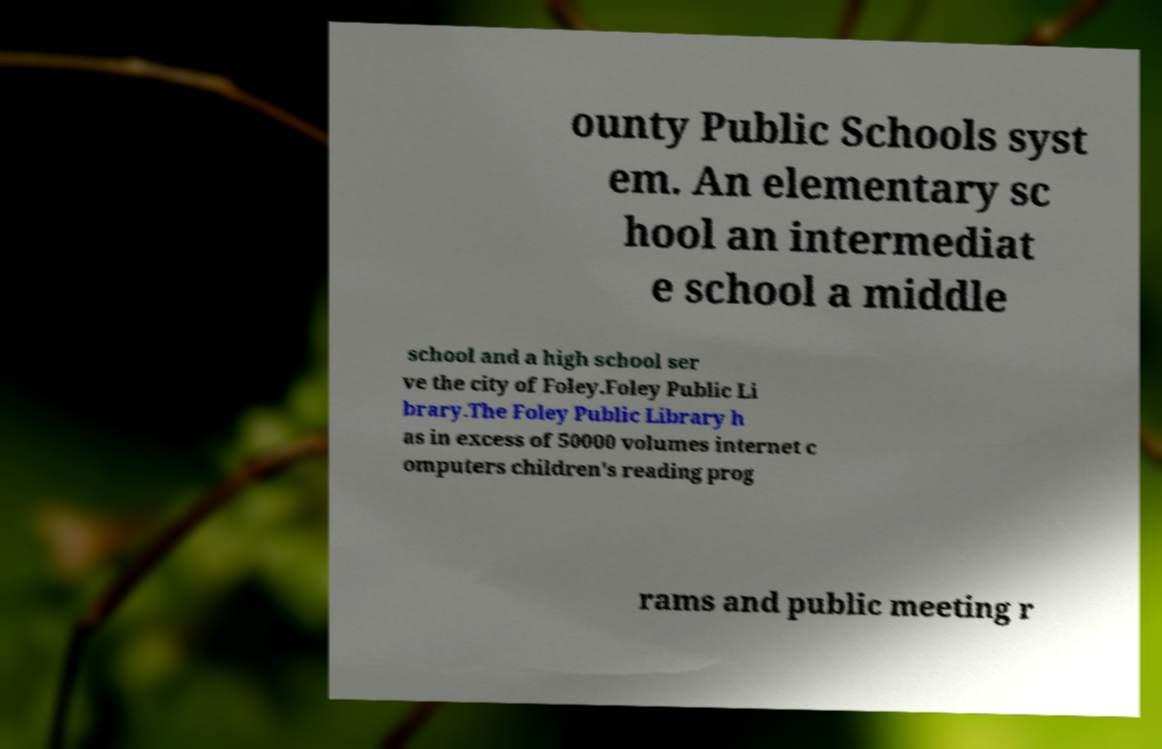There's text embedded in this image that I need extracted. Can you transcribe it verbatim? ounty Public Schools syst em. An elementary sc hool an intermediat e school a middle school and a high school ser ve the city of Foley.Foley Public Li brary.The Foley Public Library h as in excess of 50000 volumes internet c omputers children's reading prog rams and public meeting r 